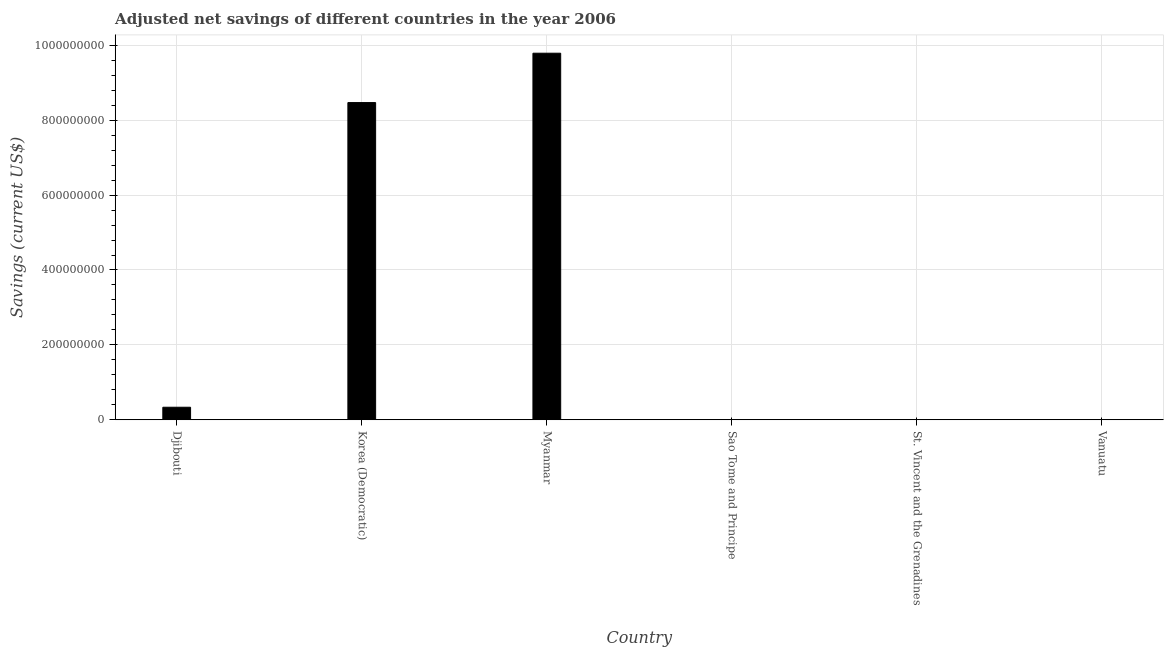Does the graph contain grids?
Ensure brevity in your answer.  Yes. What is the title of the graph?
Provide a succinct answer. Adjusted net savings of different countries in the year 2006. What is the label or title of the Y-axis?
Offer a very short reply. Savings (current US$). What is the adjusted net savings in Sao Tome and Principe?
Your answer should be very brief. 1.21e+04. Across all countries, what is the maximum adjusted net savings?
Ensure brevity in your answer.  9.79e+08. Across all countries, what is the minimum adjusted net savings?
Provide a succinct answer. 1.21e+04. In which country was the adjusted net savings maximum?
Your response must be concise. Myanmar. In which country was the adjusted net savings minimum?
Make the answer very short. Sao Tome and Principe. What is the sum of the adjusted net savings?
Ensure brevity in your answer.  1.86e+09. What is the difference between the adjusted net savings in Korea (Democratic) and Myanmar?
Keep it short and to the point. -1.32e+08. What is the average adjusted net savings per country?
Provide a succinct answer. 3.10e+08. What is the median adjusted net savings?
Offer a very short reply. 1.70e+07. In how many countries, is the adjusted net savings greater than 200000000 US$?
Provide a short and direct response. 2. What is the ratio of the adjusted net savings in Djibouti to that in Vanuatu?
Your answer should be very brief. 90.58. Is the adjusted net savings in Korea (Democratic) less than that in Sao Tome and Principe?
Ensure brevity in your answer.  No. What is the difference between the highest and the second highest adjusted net savings?
Give a very brief answer. 1.32e+08. What is the difference between the highest and the lowest adjusted net savings?
Give a very brief answer. 9.79e+08. What is the difference between two consecutive major ticks on the Y-axis?
Your answer should be compact. 2.00e+08. Are the values on the major ticks of Y-axis written in scientific E-notation?
Offer a very short reply. No. What is the Savings (current US$) of Djibouti?
Provide a succinct answer. 3.35e+07. What is the Savings (current US$) in Korea (Democratic)?
Your answer should be very brief. 8.47e+08. What is the Savings (current US$) in Myanmar?
Your response must be concise. 9.79e+08. What is the Savings (current US$) in Sao Tome and Principe?
Provide a short and direct response. 1.21e+04. What is the Savings (current US$) in St. Vincent and the Grenadines?
Give a very brief answer. 4.45e+04. What is the Savings (current US$) in Vanuatu?
Ensure brevity in your answer.  3.70e+05. What is the difference between the Savings (current US$) in Djibouti and Korea (Democratic)?
Your answer should be very brief. -8.13e+08. What is the difference between the Savings (current US$) in Djibouti and Myanmar?
Give a very brief answer. -9.45e+08. What is the difference between the Savings (current US$) in Djibouti and Sao Tome and Principe?
Provide a succinct answer. 3.35e+07. What is the difference between the Savings (current US$) in Djibouti and St. Vincent and the Grenadines?
Your answer should be very brief. 3.35e+07. What is the difference between the Savings (current US$) in Djibouti and Vanuatu?
Your answer should be very brief. 3.32e+07. What is the difference between the Savings (current US$) in Korea (Democratic) and Myanmar?
Offer a terse response. -1.32e+08. What is the difference between the Savings (current US$) in Korea (Democratic) and Sao Tome and Principe?
Give a very brief answer. 8.47e+08. What is the difference between the Savings (current US$) in Korea (Democratic) and St. Vincent and the Grenadines?
Provide a short and direct response. 8.47e+08. What is the difference between the Savings (current US$) in Korea (Democratic) and Vanuatu?
Your response must be concise. 8.47e+08. What is the difference between the Savings (current US$) in Myanmar and Sao Tome and Principe?
Make the answer very short. 9.79e+08. What is the difference between the Savings (current US$) in Myanmar and St. Vincent and the Grenadines?
Offer a very short reply. 9.79e+08. What is the difference between the Savings (current US$) in Myanmar and Vanuatu?
Your answer should be very brief. 9.78e+08. What is the difference between the Savings (current US$) in Sao Tome and Principe and St. Vincent and the Grenadines?
Your response must be concise. -3.24e+04. What is the difference between the Savings (current US$) in Sao Tome and Principe and Vanuatu?
Give a very brief answer. -3.58e+05. What is the difference between the Savings (current US$) in St. Vincent and the Grenadines and Vanuatu?
Offer a terse response. -3.26e+05. What is the ratio of the Savings (current US$) in Djibouti to that in Myanmar?
Keep it short and to the point. 0.03. What is the ratio of the Savings (current US$) in Djibouti to that in Sao Tome and Principe?
Provide a succinct answer. 2768.02. What is the ratio of the Savings (current US$) in Djibouti to that in St. Vincent and the Grenadines?
Your answer should be compact. 753.78. What is the ratio of the Savings (current US$) in Djibouti to that in Vanuatu?
Make the answer very short. 90.58. What is the ratio of the Savings (current US$) in Korea (Democratic) to that in Myanmar?
Your response must be concise. 0.86. What is the ratio of the Savings (current US$) in Korea (Democratic) to that in Sao Tome and Principe?
Provide a succinct answer. 6.99e+04. What is the ratio of the Savings (current US$) in Korea (Democratic) to that in St. Vincent and the Grenadines?
Your response must be concise. 1.90e+04. What is the ratio of the Savings (current US$) in Korea (Democratic) to that in Vanuatu?
Your answer should be very brief. 2287.25. What is the ratio of the Savings (current US$) in Myanmar to that in Sao Tome and Principe?
Your answer should be very brief. 8.08e+04. What is the ratio of the Savings (current US$) in Myanmar to that in St. Vincent and the Grenadines?
Ensure brevity in your answer.  2.20e+04. What is the ratio of the Savings (current US$) in Myanmar to that in Vanuatu?
Provide a short and direct response. 2643.14. What is the ratio of the Savings (current US$) in Sao Tome and Principe to that in St. Vincent and the Grenadines?
Keep it short and to the point. 0.27. What is the ratio of the Savings (current US$) in Sao Tome and Principe to that in Vanuatu?
Keep it short and to the point. 0.03. What is the ratio of the Savings (current US$) in St. Vincent and the Grenadines to that in Vanuatu?
Offer a terse response. 0.12. 